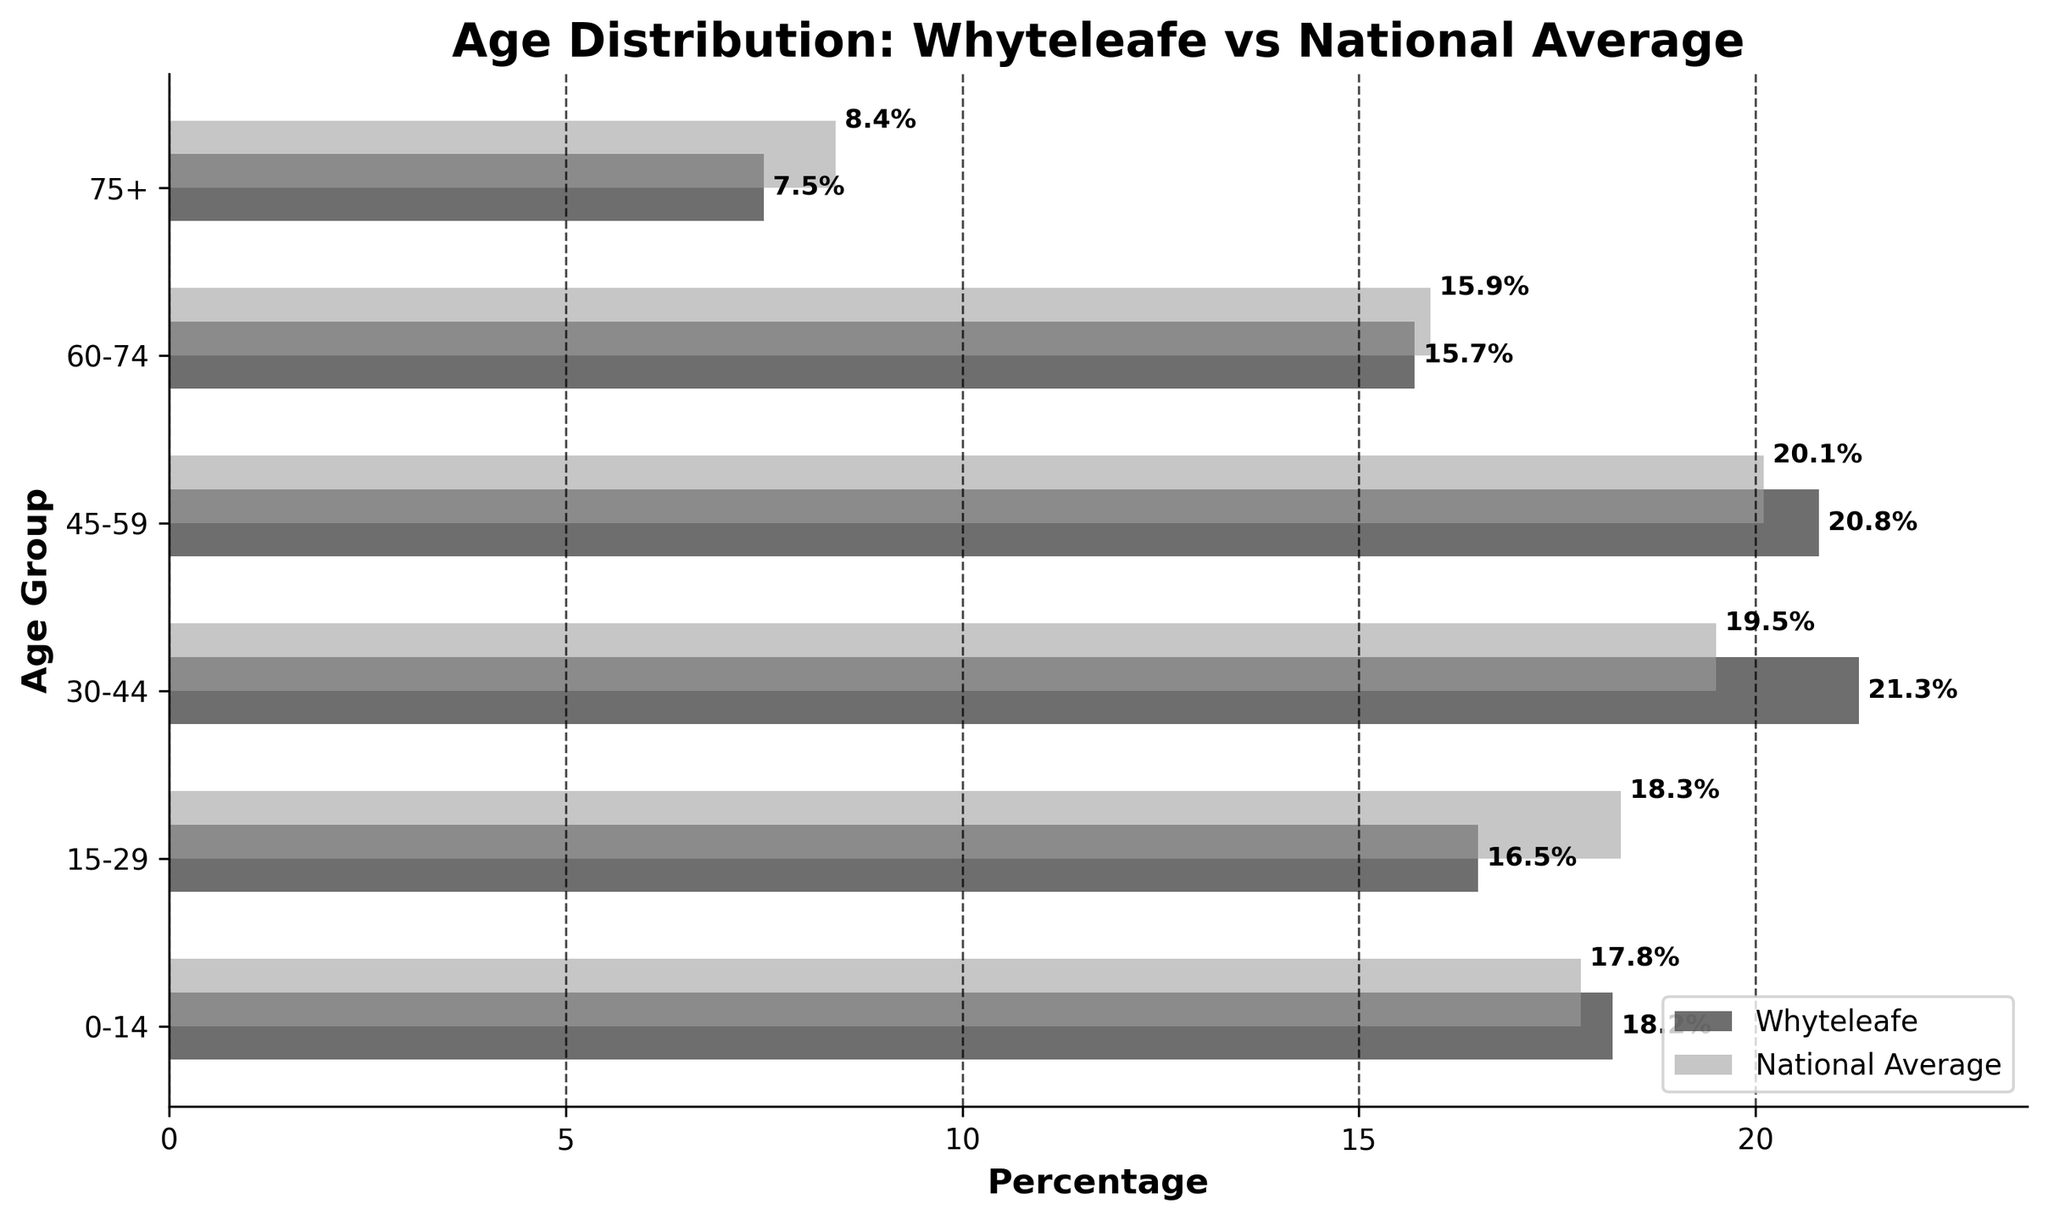What's the title of the figure? The title of a figure is usually located at the top of the chart and it tells what the chart represents. In this case, the title is "Age Distribution: Whyteleafe vs National Average".
Answer: Age Distribution: Whyteleafe vs National Average What does the x-axis represent in the plot? By observing the horizontal axis (x-axis), we can see that it represents the "Percentage" of the population in different age groups.
Answer: Percentage Which age group has the highest percentage in Whyteleafe? By comparing the lengths of the horizontal bars for Whyteleafe, the longest bar represents "30-44" age group which has a length of 21.3%.
Answer: 30-44 How much higher is the percentage of people aged 30-44 in Whyteleafe compared to the national average? To find this, subtract the national average percentage for 30-44 (19.5) from the Whyteleafe percentage for 30-44 (21.3). Therefore, 21.3 - 19.5 = 1.8%.
Answer: 1.8% In which age groups is Whyteleafe's percentage lower than the national average? By comparing the two sets of bars for each age group, we can see that Whyteleafe's percentages are lower than the national average in age groups "15-29" (16.5 < 18.3), "60-74" (15.7 < 15.9), and "75+" (7.5 < 8.4).
Answer: 15-29, 60-74, 75+ Which age group has the smallest percentage difference between Whyteleafe and the national average? To determine this, we calculate the absolute differences for each age group and find the smallest one. Differences: 0.4 (0-14), 1.8 (15-29), 1.8 (30-44), 0.7 (45-59), 0.2 (60-74), 0.9 (75+). Therefore, the smallest difference is in the 60-74 age group with 0.2%.
Answer: 60-74 What is the total percentage of the population in Whyteleafe for age groups 0-14 and 75+ combined? Add the percentages for the age groups 0-14 (18.2) and 75+ (7.5). Therefore, 18.2 + 7.5 = 25.7%.
Answer: 25.7% Which has a higher proportion in the 45-59 age group, Whyteleafe or the national average? By comparing the lengths of the corresponding bars, Whyteleafe has 20.8% and the national average has 20.1%. Therefore, Whyteleafe has a higher proportion.
Answer: Whyteleafe What is the average percentage of Whyteleafe residents across all age groups? To find the average, sum up the percentages and divide by the number of age groups: (18.2 + 16.5 + 21.3 + 20.8 + 15.7 + 7.5) / 6 = 100 / 6 = 16.66%.
Answer: 16.66% 